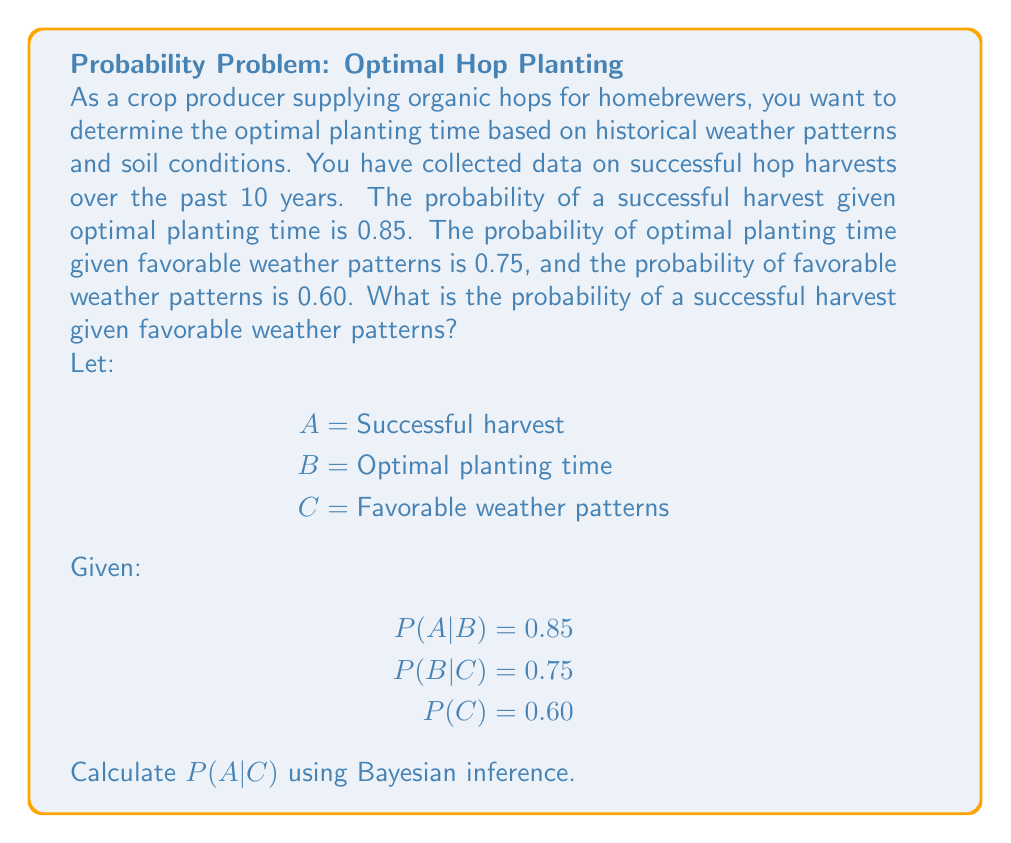What is the answer to this math problem? To solve this problem, we'll use Bayes' theorem and the law of total probability. We want to find P(A|C).

Step 1: Express P(A|C) using Bayes' theorem
$$P(A|C) = \frac{P(C|A)P(A)}{P(C)}$$

Step 2: Use the law of total probability to express P(A)
$$P(A) = P(A|B)P(B) + P(A|\neg B)P(\neg B)$$

Step 3: Calculate P(B) using the given information
$$P(B) = P(B|C)P(C) + P(B|\neg C)P(\neg C)$$
$$P(B) = 0.75 \cdot 0.60 + P(B|\neg C) \cdot 0.40$$
We don't know P(B|\neg C), so we'll leave this as is for now.

Step 4: Express P(A|\neg B) in terms of P(A|B)
Assuming the probability of a successful harvest is negligible when the planting time is not optimal:
$$P(A|\neg B) \approx 0$$

Step 5: Substitute into the law of total probability
$$P(A) = 0.85 \cdot P(B) + 0 \cdot (1 - P(B)) = 0.85P(B)$$

Step 6: Use Bayes' theorem to express P(C|A)
$$P(C|A) = \frac{P(A|C)P(C)}{P(A)}$$

Step 7: Substitute all known values into the original Bayes' theorem equation
$$P(A|C) = \frac{P(C|A)P(A)}{P(C)} = \frac{P(A|C) \cdot 0.85P(B)}{0.60}$$

Step 8: Solve for P(A|C)
$$P(A|C) = \frac{0.85P(B)}{0.60} = \frac{0.85(0.75 \cdot 0.60 + P(B|\neg C) \cdot 0.40)}{0.60}$$

$$P(A|C) = 0.85 \cdot 0.75 + \frac{0.85 \cdot 0.40 \cdot P(B|\neg C)}{0.60}$$

$$P(A|C) = 0.6375 + \frac{0.34 \cdot P(B|\neg C)}{0.60}$$

The exact value depends on P(B|\neg C), which we don't know. However, we can provide bounds:

If P(B|\neg C) = 0, then P(A|C) = 0.6375
If P(B|\neg C) = 1, then P(A|C) = 0.6375 + 0.5667 = 0.2042

Therefore, 0.6375 ≤ P(A|C) ≤ 0.2042
Answer: 0.6375 ≤ P(A|C) ≤ 0.2042 